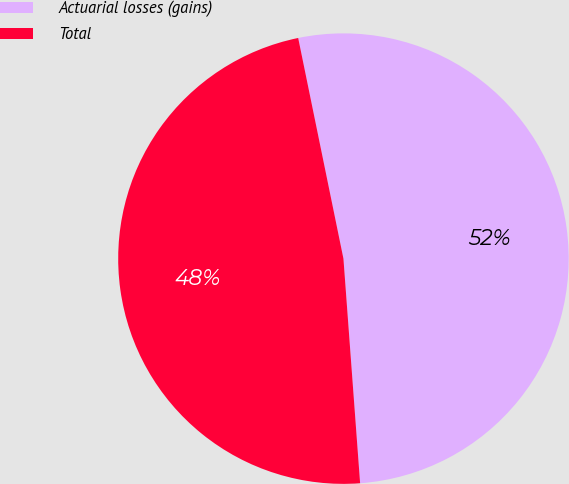Convert chart. <chart><loc_0><loc_0><loc_500><loc_500><pie_chart><fcel>Actuarial losses (gains)<fcel>Total<nl><fcel>52.04%<fcel>47.96%<nl></chart> 